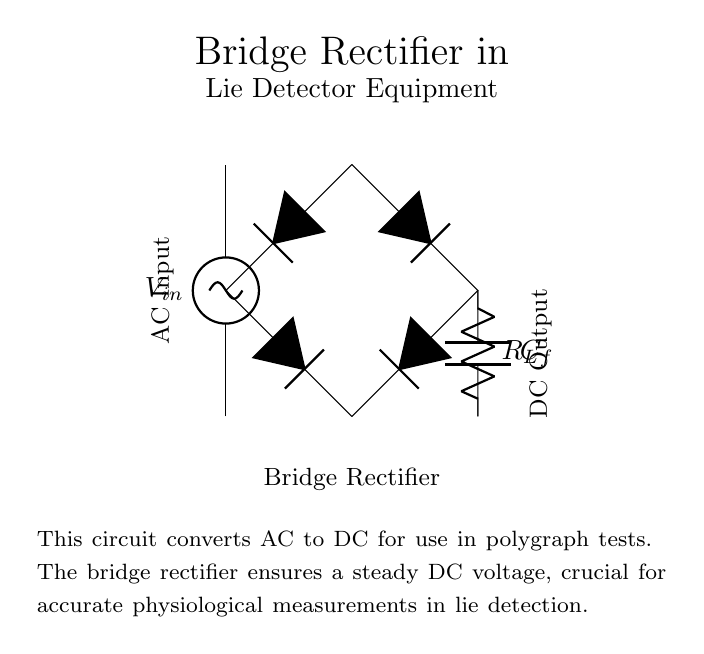What does the input represent in this circuit? The input is labeled as V_in, indicating it is the AC voltage supply for the bridge rectifier. This voltage is the source of energy that the circuit converts from alternating current (AC) to direct current (DC).
Answer: V_in What are the components in the rectifier? The components in the bridge rectifier include diodes, a resistor (R_L), and a capacitor (C_f). These components are essential for converting AC to DC, with diodes providing the rectification, the resistor acting as a load, and the capacitor smoothing the output voltage.
Answer: Diodes, resistor, capacitor What type of rectifier is shown in the diagram? The circuit is a bridge rectifier, as it features four diodes arranged in a bridge configuration to allow current to flow in one direction. This design is specifically utilized for its efficiency in converting AC to DC while using a smaller number of components compared to other rectifier types.
Answer: Bridge rectifier What purpose does the capacitor serve in the circuit? The capacitor (C_f) serves to smooth the output voltage by filtering out the fluctuations in the rectified voltage, resulting in a more stable and uniform DC output. This stabilization is critical for accurate readings in lie detection equipment.
Answer: Smoothing the output How does the bridge rectifier improve measurement accuracy in lie detector tests? The bridge rectifier ensures a steady and stable DC voltage supply, which is crucial for the proper functioning of the sensors in lie detectors. A consistent voltage allows for more accurate physiological measurements, as variations in voltage can lead to misleading results during a polygraph test.
Answer: Improved measurement accuracy 